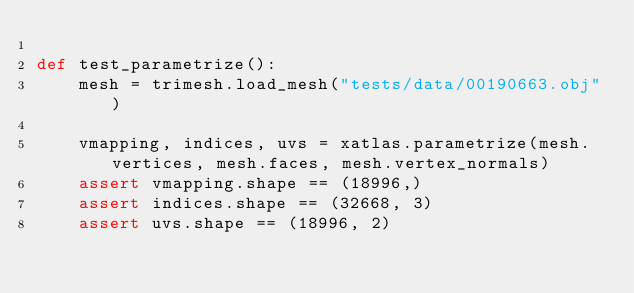<code> <loc_0><loc_0><loc_500><loc_500><_Python_>
def test_parametrize():
    mesh = trimesh.load_mesh("tests/data/00190663.obj")

    vmapping, indices, uvs = xatlas.parametrize(mesh.vertices, mesh.faces, mesh.vertex_normals)
    assert vmapping.shape == (18996,)
    assert indices.shape == (32668, 3)
    assert uvs.shape == (18996, 2)</code> 